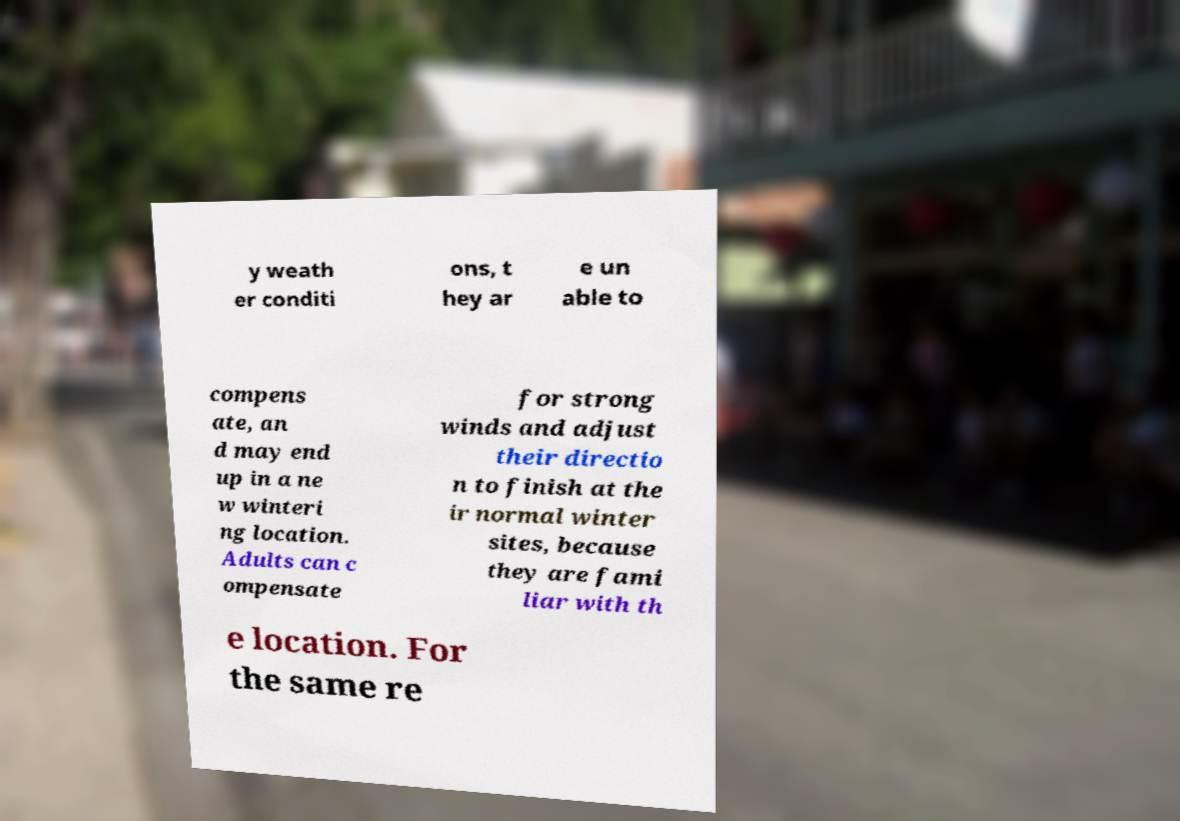What messages or text are displayed in this image? I need them in a readable, typed format. y weath er conditi ons, t hey ar e un able to compens ate, an d may end up in a ne w winteri ng location. Adults can c ompensate for strong winds and adjust their directio n to finish at the ir normal winter sites, because they are fami liar with th e location. For the same re 